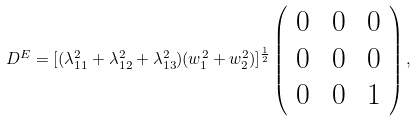Convert formula to latex. <formula><loc_0><loc_0><loc_500><loc_500>D ^ { E } = [ ( \lambda _ { 1 1 } ^ { 2 } + \lambda _ { 1 2 } ^ { 2 } + \lambda _ { 1 3 } ^ { 2 } ) ( w _ { 1 } ^ { 2 } + w _ { 2 } ^ { 2 } ) ] ^ { \frac { 1 } { 2 } } \left ( \begin{array} { c c c } { 0 \, } & { 0 \, } & { 0 } \\ { 0 \, } & { 0 \, } & { 0 } \\ { 0 \, } & { 0 \, } & { 1 } \end{array} \right ) ,</formula> 